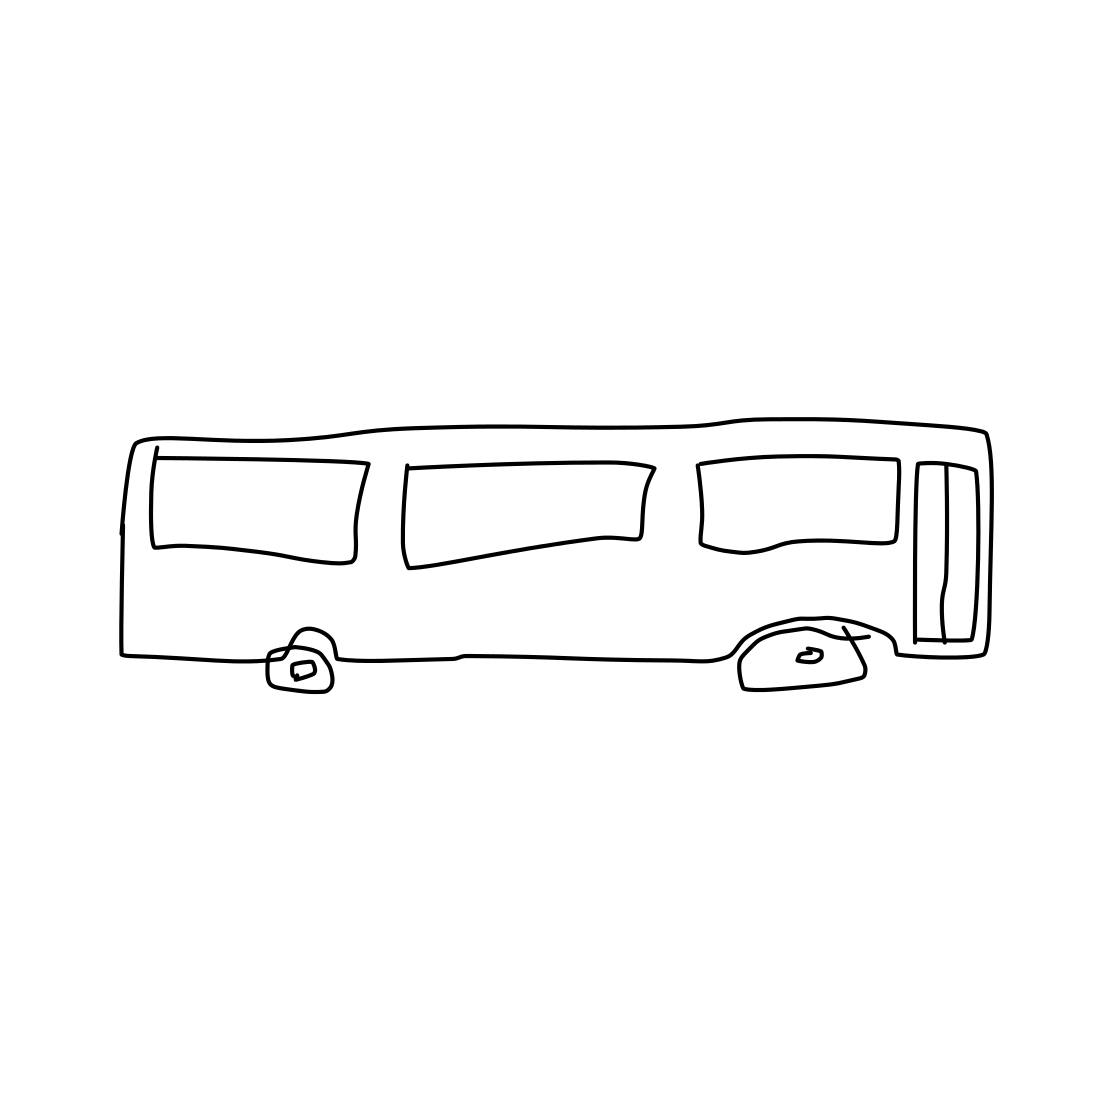Could this image serve an educational purpose? Absolutely, this type of image could be used in educational materials to teach about transportation, vehicle identification, or as part of a coloring activity for younger children due to its simplicity and clear outlines. How could this image be made more detailed and realistic? Adding depth through shading, details like mirrors, door handles, wheels, and texture, as well as including environmental context like streets or backgrounds, would make the image more detailed and realistic. 